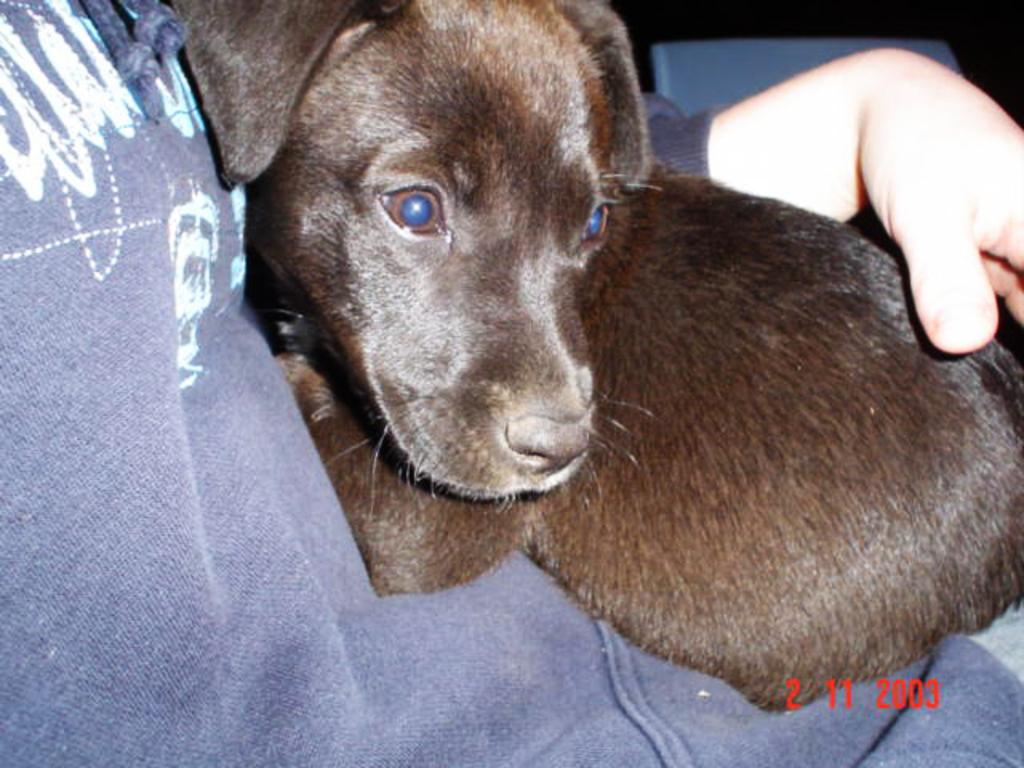What is the main subject of the image? There is a person in the image. What is the person doing in the image? The person is holding a dog. Can you describe the dog in the image? The dog is brown in color. What type of ink is being used to write on the dog in the image? There is no ink or writing present on the dog in the image. The dog is simply being held by the person. 